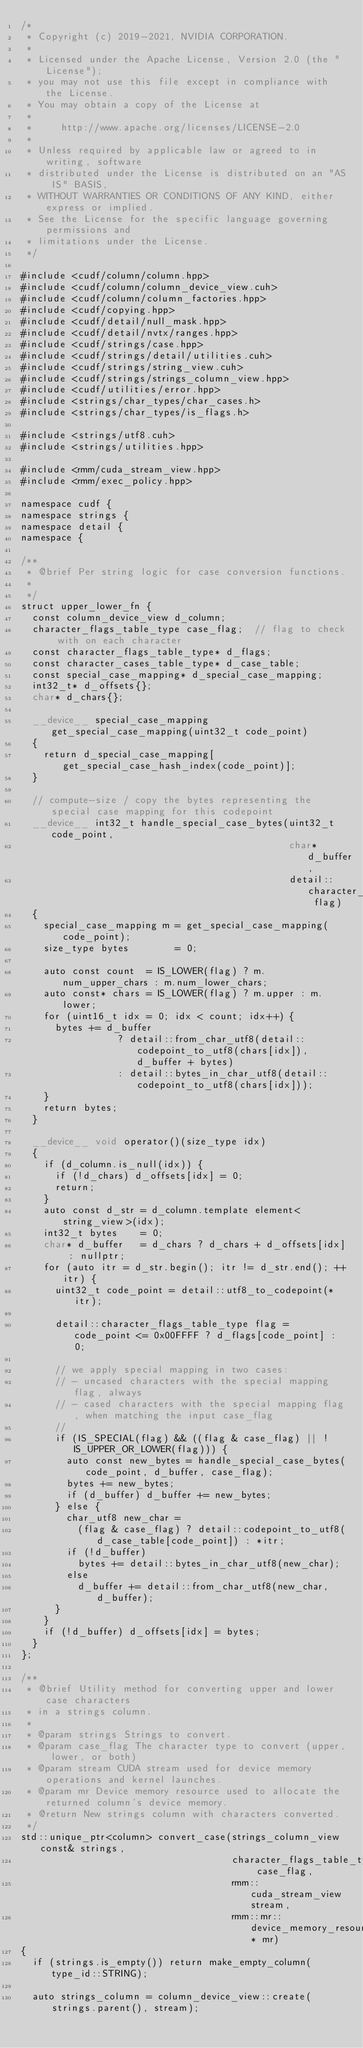<code> <loc_0><loc_0><loc_500><loc_500><_Cuda_>/*
 * Copyright (c) 2019-2021, NVIDIA CORPORATION.
 *
 * Licensed under the Apache License, Version 2.0 (the "License");
 * you may not use this file except in compliance with the License.
 * You may obtain a copy of the License at
 *
 *     http://www.apache.org/licenses/LICENSE-2.0
 *
 * Unless required by applicable law or agreed to in writing, software
 * distributed under the License is distributed on an "AS IS" BASIS,
 * WITHOUT WARRANTIES OR CONDITIONS OF ANY KIND, either express or implied.
 * See the License for the specific language governing permissions and
 * limitations under the License.
 */

#include <cudf/column/column.hpp>
#include <cudf/column/column_device_view.cuh>
#include <cudf/column/column_factories.hpp>
#include <cudf/copying.hpp>
#include <cudf/detail/null_mask.hpp>
#include <cudf/detail/nvtx/ranges.hpp>
#include <cudf/strings/case.hpp>
#include <cudf/strings/detail/utilities.cuh>
#include <cudf/strings/string_view.cuh>
#include <cudf/strings/strings_column_view.hpp>
#include <cudf/utilities/error.hpp>
#include <strings/char_types/char_cases.h>
#include <strings/char_types/is_flags.h>

#include <strings/utf8.cuh>
#include <strings/utilities.hpp>

#include <rmm/cuda_stream_view.hpp>
#include <rmm/exec_policy.hpp>

namespace cudf {
namespace strings {
namespace detail {
namespace {

/**
 * @brief Per string logic for case conversion functions.
 *
 */
struct upper_lower_fn {
  const column_device_view d_column;
  character_flags_table_type case_flag;  // flag to check with on each character
  const character_flags_table_type* d_flags;
  const character_cases_table_type* d_case_table;
  const special_case_mapping* d_special_case_mapping;
  int32_t* d_offsets{};
  char* d_chars{};

  __device__ special_case_mapping get_special_case_mapping(uint32_t code_point)
  {
    return d_special_case_mapping[get_special_case_hash_index(code_point)];
  }

  // compute-size / copy the bytes representing the special case mapping for this codepoint
  __device__ int32_t handle_special_case_bytes(uint32_t code_point,
                                               char* d_buffer,
                                               detail::character_flags_table_type flag)
  {
    special_case_mapping m = get_special_case_mapping(code_point);
    size_type bytes        = 0;

    auto const count  = IS_LOWER(flag) ? m.num_upper_chars : m.num_lower_chars;
    auto const* chars = IS_LOWER(flag) ? m.upper : m.lower;
    for (uint16_t idx = 0; idx < count; idx++) {
      bytes += d_buffer
                 ? detail::from_char_utf8(detail::codepoint_to_utf8(chars[idx]), d_buffer + bytes)
                 : detail::bytes_in_char_utf8(detail::codepoint_to_utf8(chars[idx]));
    }
    return bytes;
  }

  __device__ void operator()(size_type idx)
  {
    if (d_column.is_null(idx)) {
      if (!d_chars) d_offsets[idx] = 0;
      return;
    }
    auto const d_str = d_column.template element<string_view>(idx);
    int32_t bytes    = 0;
    char* d_buffer   = d_chars ? d_chars + d_offsets[idx] : nullptr;
    for (auto itr = d_str.begin(); itr != d_str.end(); ++itr) {
      uint32_t code_point = detail::utf8_to_codepoint(*itr);

      detail::character_flags_table_type flag = code_point <= 0x00FFFF ? d_flags[code_point] : 0;

      // we apply special mapping in two cases:
      // - uncased characters with the special mapping flag, always
      // - cased characters with the special mapping flag, when matching the input case_flag
      //
      if (IS_SPECIAL(flag) && ((flag & case_flag) || !IS_UPPER_OR_LOWER(flag))) {
        auto const new_bytes = handle_special_case_bytes(code_point, d_buffer, case_flag);
        bytes += new_bytes;
        if (d_buffer) d_buffer += new_bytes;
      } else {
        char_utf8 new_char =
          (flag & case_flag) ? detail::codepoint_to_utf8(d_case_table[code_point]) : *itr;
        if (!d_buffer)
          bytes += detail::bytes_in_char_utf8(new_char);
        else
          d_buffer += detail::from_char_utf8(new_char, d_buffer);
      }
    }
    if (!d_buffer) d_offsets[idx] = bytes;
  }
};

/**
 * @brief Utility method for converting upper and lower case characters
 * in a strings column.
 *
 * @param strings Strings to convert.
 * @param case_flag The character type to convert (upper, lower, or both)
 * @param stream CUDA stream used for device memory operations and kernel launches.
 * @param mr Device memory resource used to allocate the returned column's device memory.
 * @return New strings column with characters converted.
 */
std::unique_ptr<column> convert_case(strings_column_view const& strings,
                                     character_flags_table_type case_flag,
                                     rmm::cuda_stream_view stream,
                                     rmm::mr::device_memory_resource* mr)
{
  if (strings.is_empty()) return make_empty_column(type_id::STRING);

  auto strings_column = column_device_view::create(strings.parent(), stream);</code> 